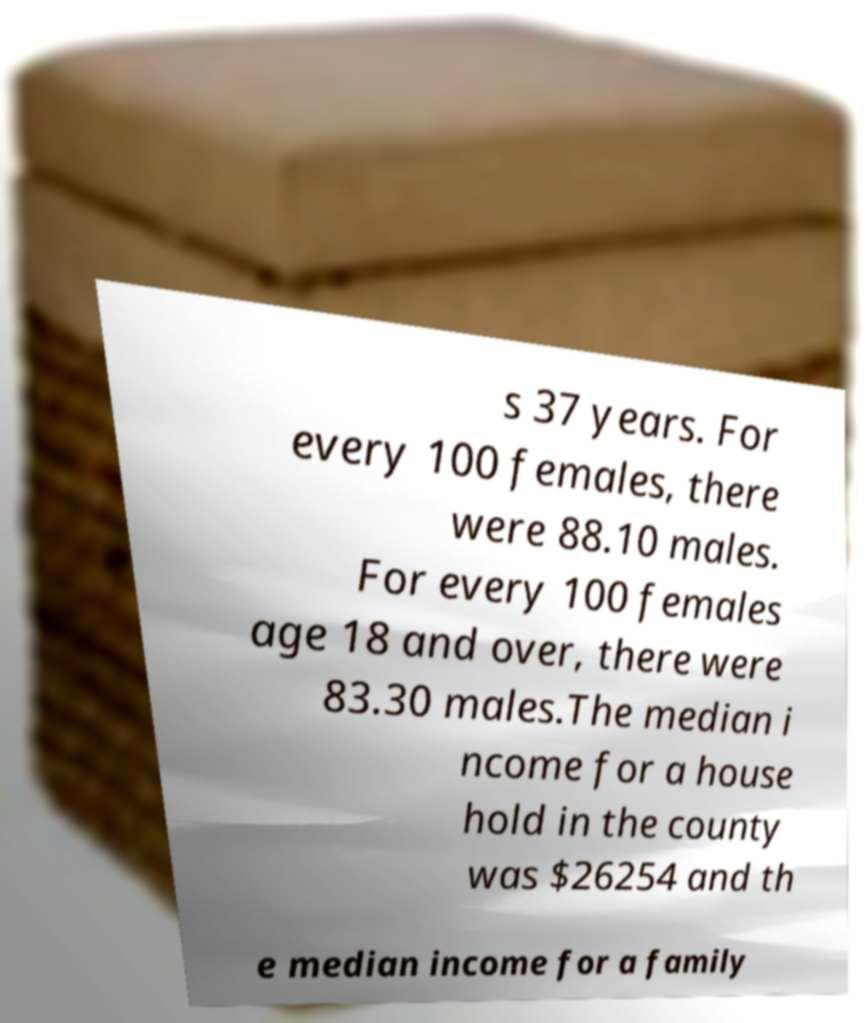For documentation purposes, I need the text within this image transcribed. Could you provide that? s 37 years. For every 100 females, there were 88.10 males. For every 100 females age 18 and over, there were 83.30 males.The median i ncome for a house hold in the county was $26254 and th e median income for a family 